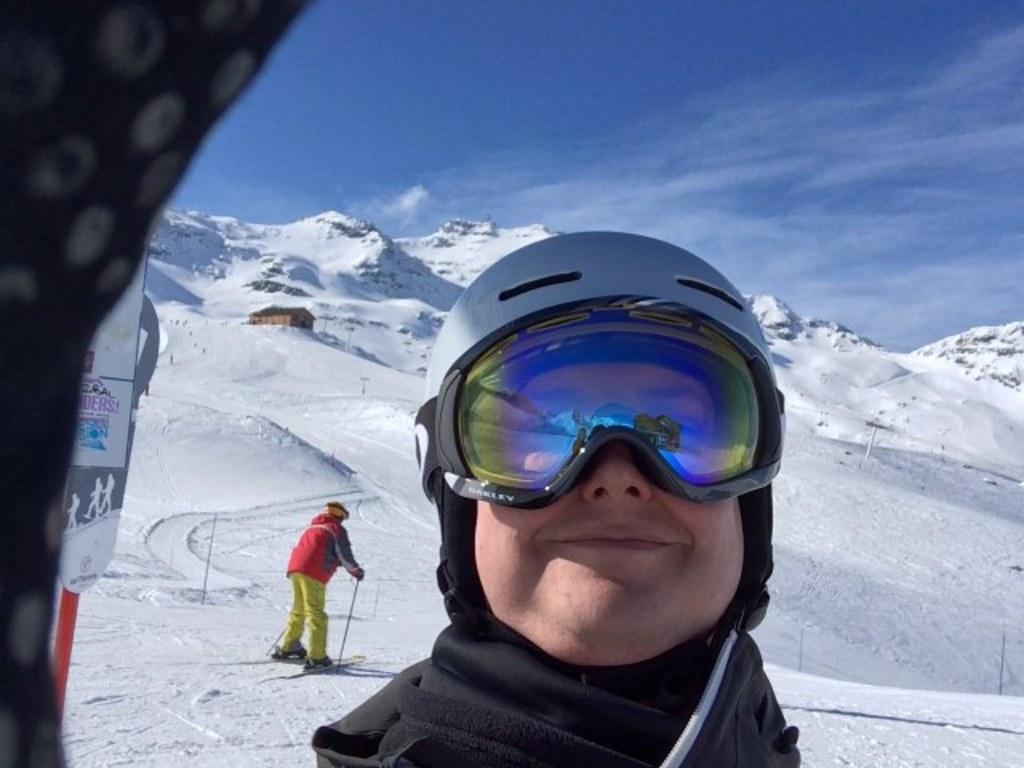Please provide a concise description of this image. In this image we can see a person wearing glasses on his face is standing. In the background we can see mountains with ice, a person standing on skateboard and clouds. 